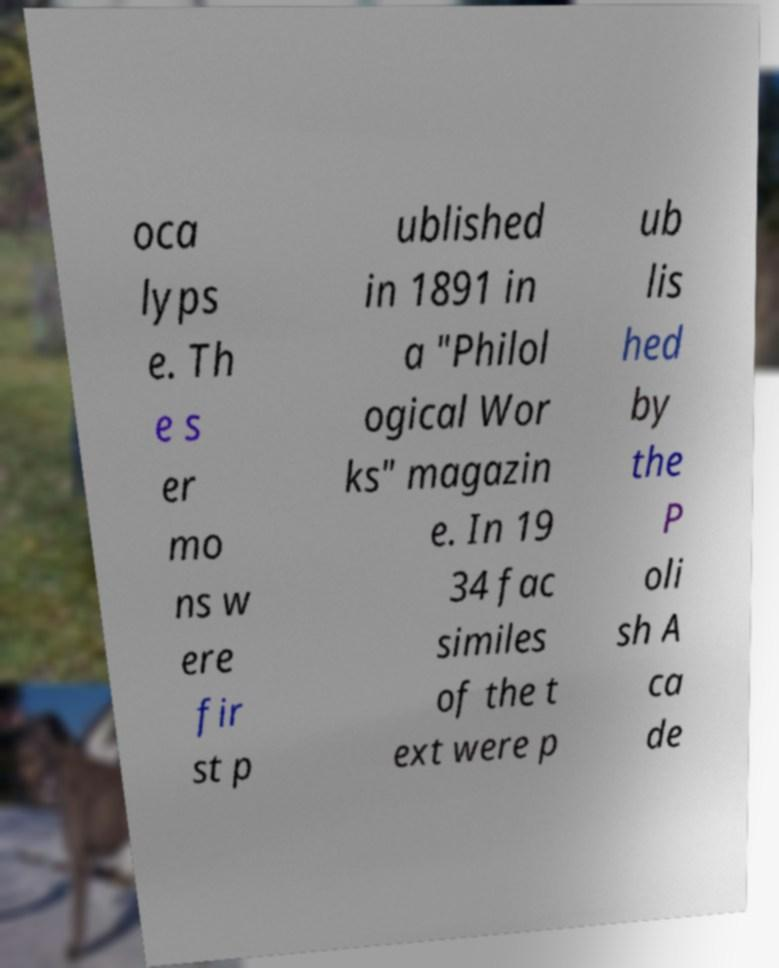Can you read and provide the text displayed in the image?This photo seems to have some interesting text. Can you extract and type it out for me? oca lyps e. Th e s er mo ns w ere fir st p ublished in 1891 in a "Philol ogical Wor ks" magazin e. In 19 34 fac similes of the t ext were p ub lis hed by the P oli sh A ca de 